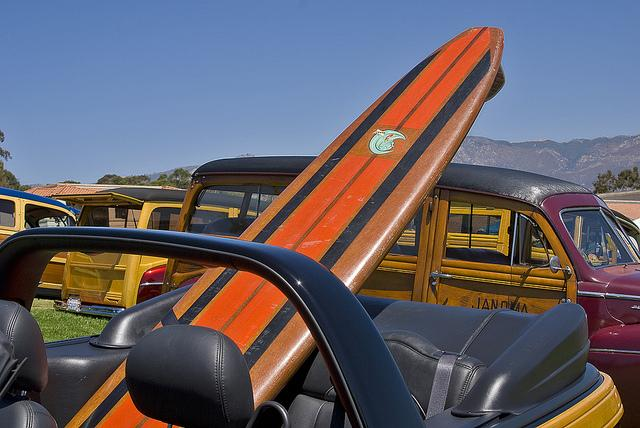Who played the character on the Brady Bunch whose name can be spelled with the first three letters shown on the vehicle?

Choices:
A) eve plumb
B) christopher knight
C) mike lookinland
D) susan olsen eve plumb 